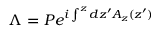<formula> <loc_0><loc_0><loc_500><loc_500>\Lambda = P e ^ { i \int ^ { z } d z ^ { \prime } A _ { z } ( z ^ { \prime } ) }</formula> 